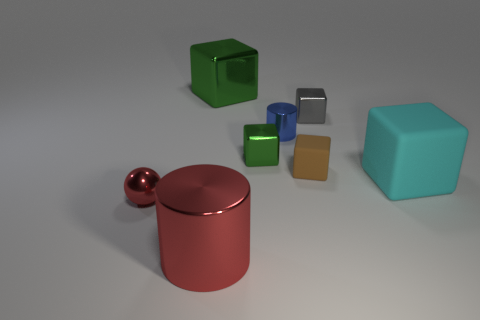Add 2 small blue shiny cylinders. How many objects exist? 10 Subtract all matte cubes. How many cubes are left? 3 Subtract 3 blocks. How many blocks are left? 2 Subtract all cyan blocks. How many blocks are left? 4 Subtract all cylinders. How many objects are left? 6 Subtract all yellow cylinders. Subtract all green spheres. How many cylinders are left? 2 Subtract all yellow balls. How many brown cylinders are left? 0 Subtract all blue objects. Subtract all small green cubes. How many objects are left? 6 Add 1 red shiny cylinders. How many red shiny cylinders are left? 2 Add 1 small cyan metallic blocks. How many small cyan metallic blocks exist? 1 